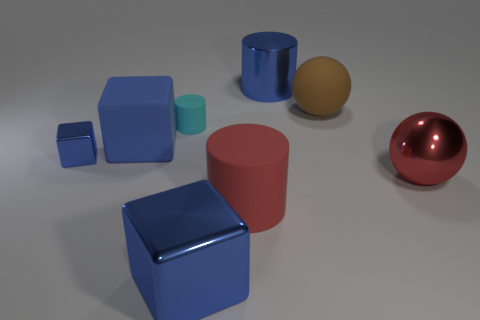How many other things are there of the same color as the big shiny ball? Including the big shiny ball, there is one item of the same glossy red color in the scene. It's the spherical object located to the right. 